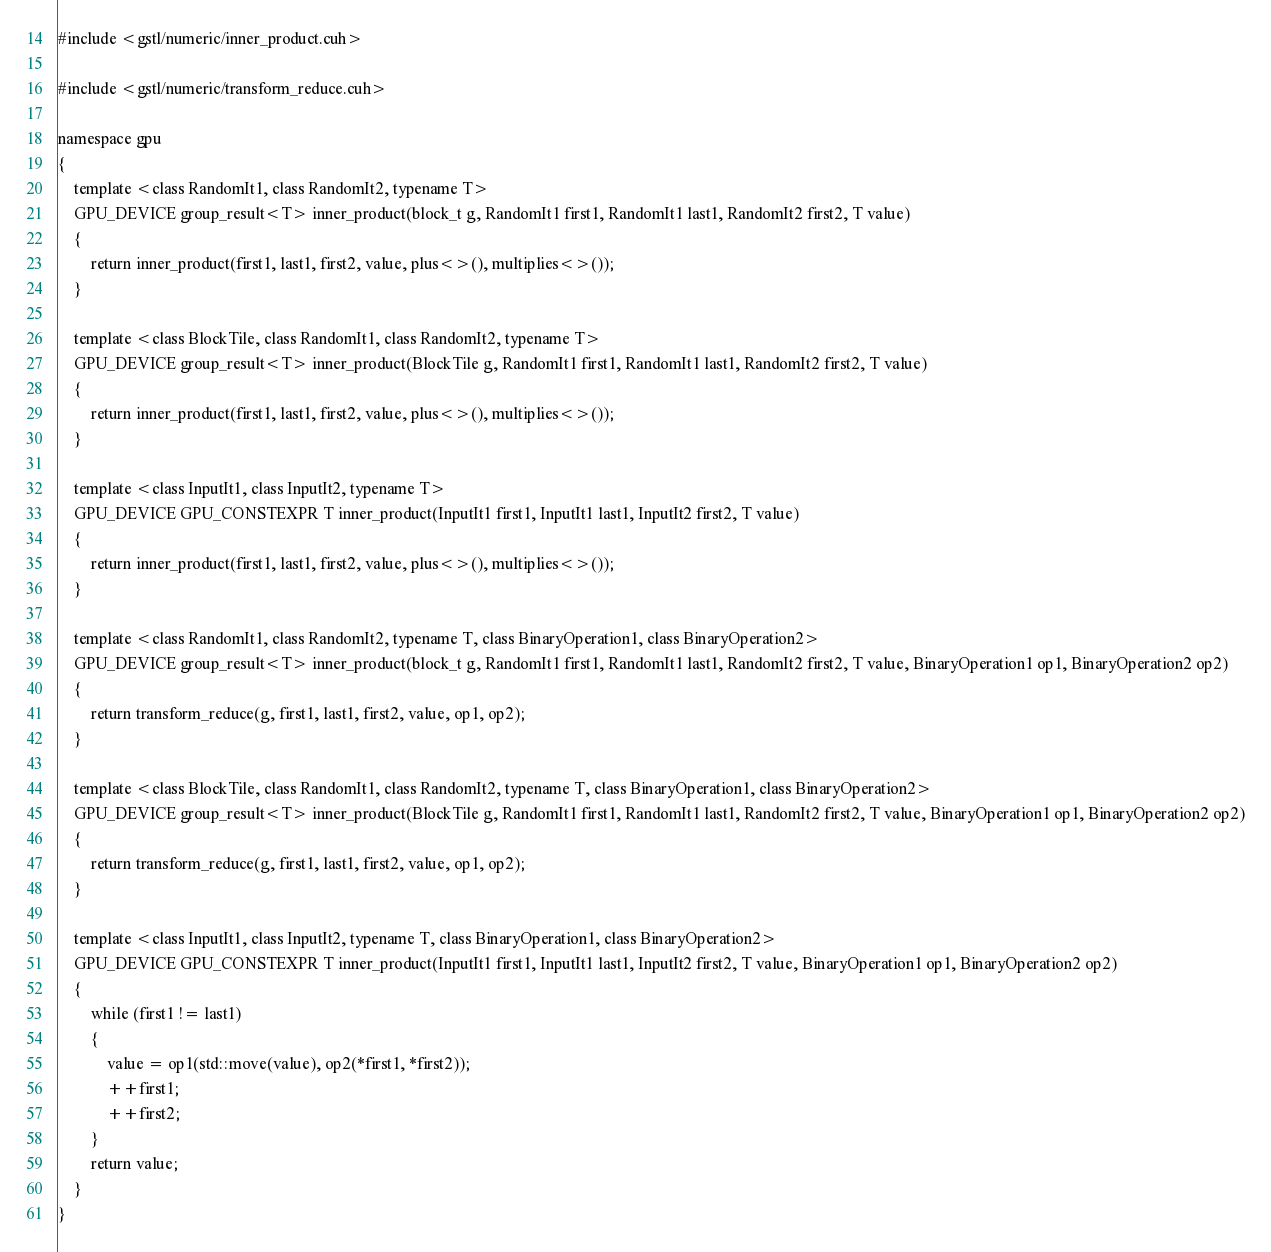Convert code to text. <code><loc_0><loc_0><loc_500><loc_500><_Cuda_>#include <gstl/numeric/inner_product.cuh>

#include <gstl/numeric/transform_reduce.cuh>

namespace gpu
{
	template <class RandomIt1, class RandomIt2, typename T>
	GPU_DEVICE group_result<T> inner_product(block_t g, RandomIt1 first1, RandomIt1 last1, RandomIt2 first2, T value)
	{
		return inner_product(first1, last1, first2, value, plus<>(), multiplies<>());
	}

	template <class BlockTile, class RandomIt1, class RandomIt2, typename T>
	GPU_DEVICE group_result<T> inner_product(BlockTile g, RandomIt1 first1, RandomIt1 last1, RandomIt2 first2, T value)
	{
		return inner_product(first1, last1, first2, value, plus<>(), multiplies<>());
	}

	template <class InputIt1, class InputIt2, typename T>
	GPU_DEVICE GPU_CONSTEXPR T inner_product(InputIt1 first1, InputIt1 last1, InputIt2 first2, T value)
	{
		return inner_product(first1, last1, first2, value, plus<>(), multiplies<>());
	}

	template <class RandomIt1, class RandomIt2, typename T, class BinaryOperation1, class BinaryOperation2>
	GPU_DEVICE group_result<T> inner_product(block_t g, RandomIt1 first1, RandomIt1 last1, RandomIt2 first2, T value, BinaryOperation1 op1, BinaryOperation2 op2)
	{
		return transform_reduce(g, first1, last1, first2, value, op1, op2);
	}

	template <class BlockTile, class RandomIt1, class RandomIt2, typename T, class BinaryOperation1, class BinaryOperation2>
	GPU_DEVICE group_result<T> inner_product(BlockTile g, RandomIt1 first1, RandomIt1 last1, RandomIt2 first2, T value, BinaryOperation1 op1, BinaryOperation2 op2)
	{
		return transform_reduce(g, first1, last1, first2, value, op1, op2);
	}

	template <class InputIt1, class InputIt2, typename T, class BinaryOperation1, class BinaryOperation2>
	GPU_DEVICE GPU_CONSTEXPR T inner_product(InputIt1 first1, InputIt1 last1, InputIt2 first2, T value, BinaryOperation1 op1, BinaryOperation2 op2)
	{
		while (first1 != last1)
		{
			value = op1(std::move(value), op2(*first1, *first2));
			++first1;
			++first2;
		}
		return value;
	}
}
</code> 